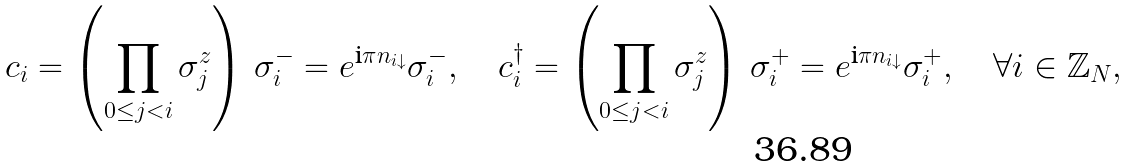Convert formula to latex. <formula><loc_0><loc_0><loc_500><loc_500>c _ { i } = \left ( \prod _ { 0 \leq j < i } \sigma ^ { z } _ { j } \right ) \, \sigma _ { i } ^ { - } = e ^ { \text {i} \pi n _ { i \downarrow } } \sigma _ { i } ^ { - } , \quad c _ { i } ^ { \dag } = \left ( \prod _ { 0 \leq j < i } \sigma ^ { z } _ { j } \right ) \, \sigma _ { i } ^ { + } = e ^ { \text {i} \pi n _ { i \downarrow } } \sigma _ { i } ^ { + } , \quad \forall i \in \mathbb { Z } _ { N } ,</formula> 